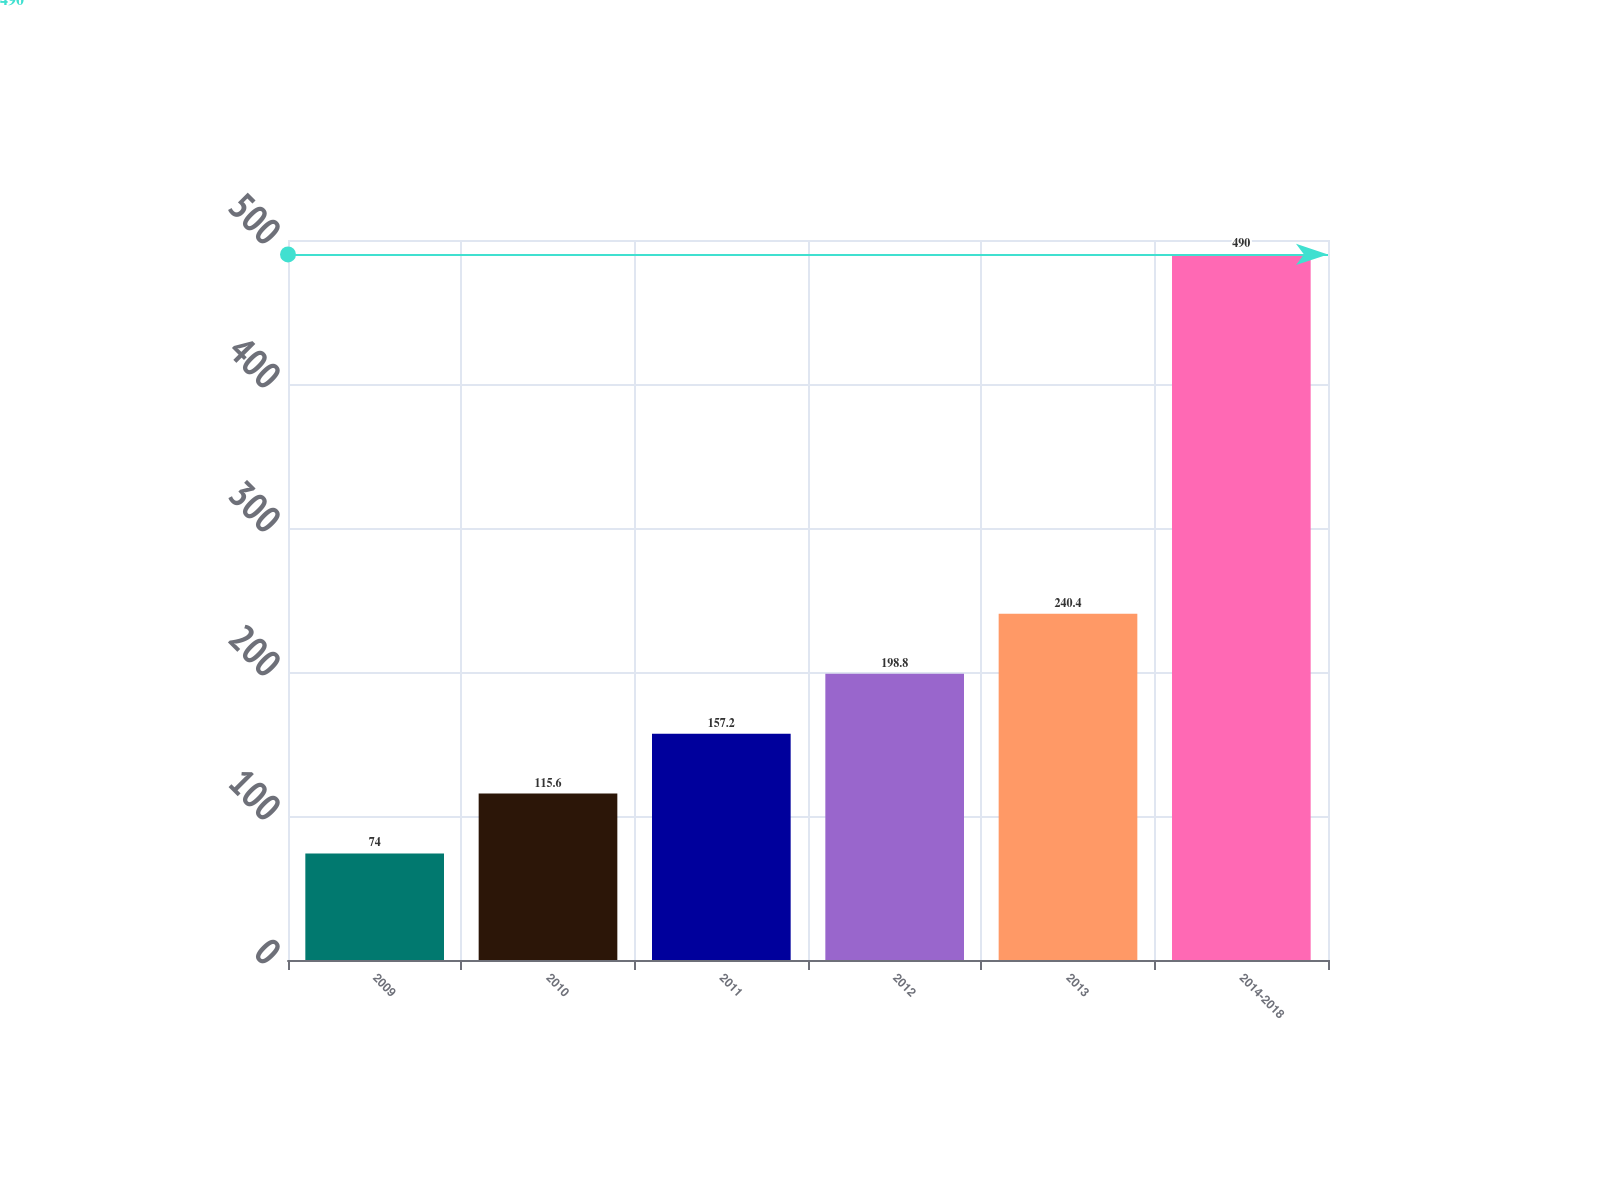Convert chart. <chart><loc_0><loc_0><loc_500><loc_500><bar_chart><fcel>2009<fcel>2010<fcel>2011<fcel>2012<fcel>2013<fcel>2014-2018<nl><fcel>74<fcel>115.6<fcel>157.2<fcel>198.8<fcel>240.4<fcel>490<nl></chart> 